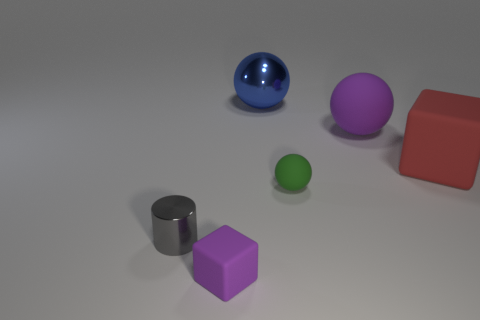Subtract all rubber spheres. How many spheres are left? 1 Subtract all green balls. How many balls are left? 2 Subtract 1 gray cylinders. How many objects are left? 5 Subtract all cylinders. How many objects are left? 5 Subtract 1 blocks. How many blocks are left? 1 Subtract all purple cylinders. Subtract all gray blocks. How many cylinders are left? 1 Subtract all gray cubes. How many green balls are left? 1 Subtract all red rubber things. Subtract all rubber spheres. How many objects are left? 3 Add 5 tiny purple rubber objects. How many tiny purple rubber objects are left? 6 Add 5 large red metal balls. How many large red metal balls exist? 5 